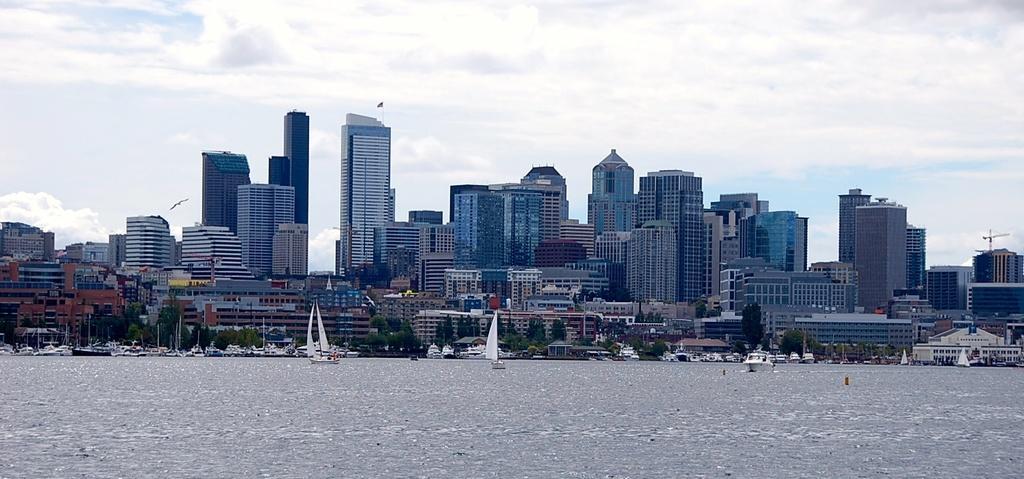In one or two sentences, can you explain what this image depicts? In this image we can see the buildings. And we can see the boats in the water. And we can see the trees. And we can see the clouds in the sky. 